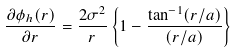Convert formula to latex. <formula><loc_0><loc_0><loc_500><loc_500>\frac { \partial \phi _ { h } ( r ) } { \partial r } = \frac { 2 \sigma ^ { 2 } } { r } \left \{ 1 - \frac { \tan ^ { - 1 } ( r / a ) } { ( r / a ) } \right \}</formula> 